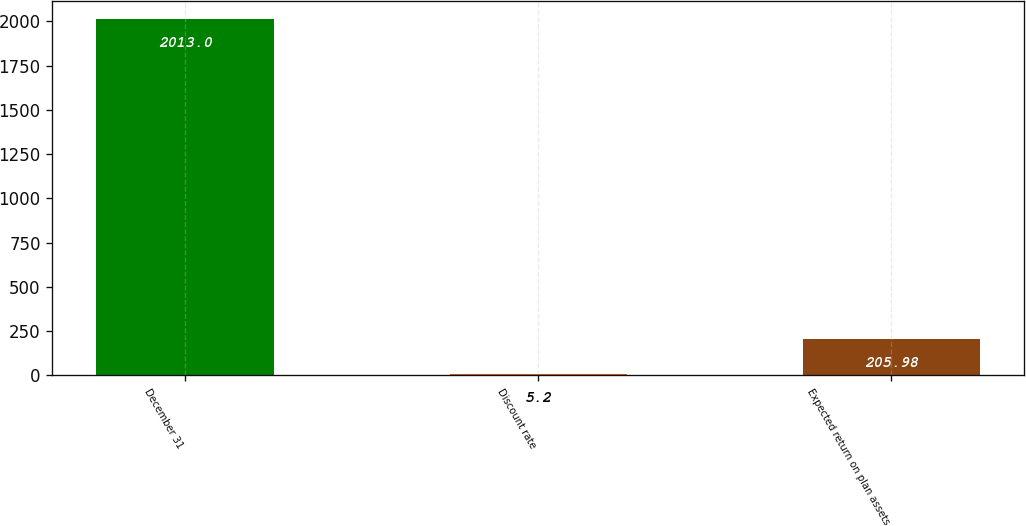<chart> <loc_0><loc_0><loc_500><loc_500><bar_chart><fcel>December 31<fcel>Discount rate<fcel>Expected return on plan assets<nl><fcel>2013<fcel>5.2<fcel>205.98<nl></chart> 